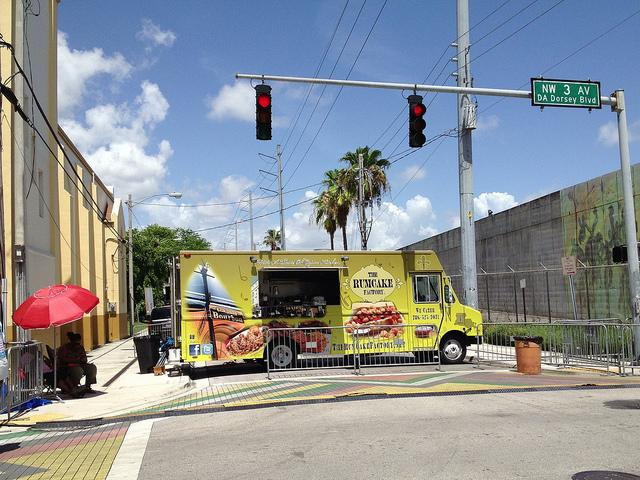What is the yellow truck doing? selling food 